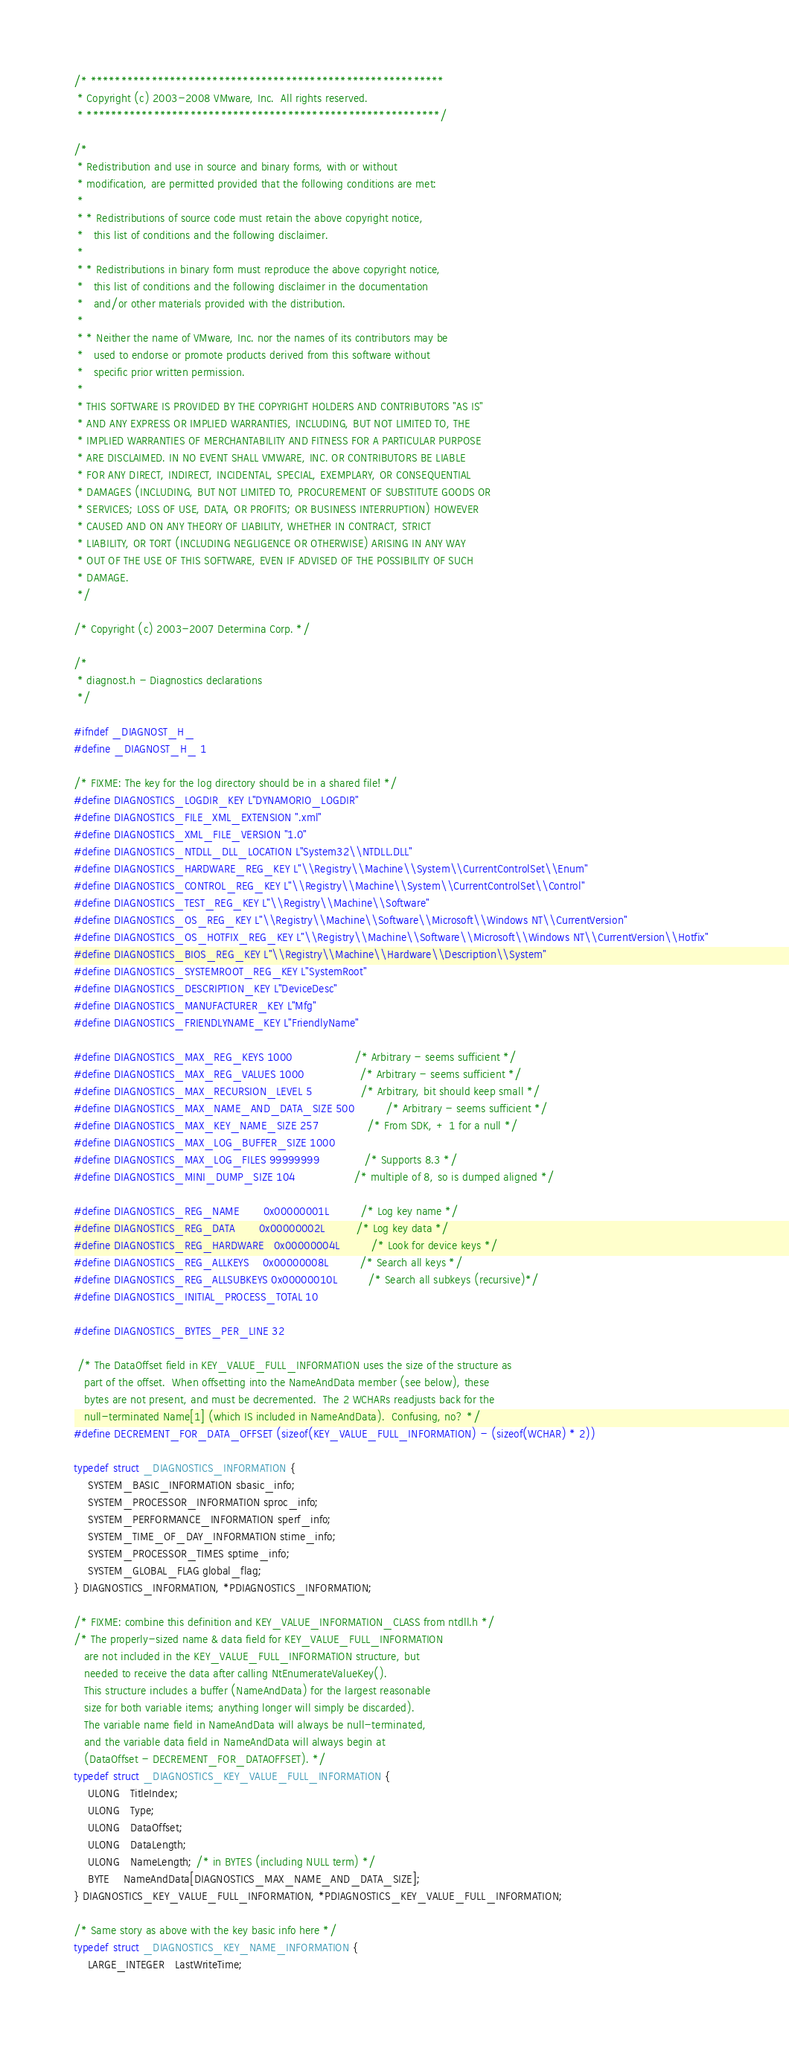Convert code to text. <code><loc_0><loc_0><loc_500><loc_500><_C_>/* **********************************************************
 * Copyright (c) 2003-2008 VMware, Inc.  All rights reserved.
 * **********************************************************/

/*
 * Redistribution and use in source and binary forms, with or without
 * modification, are permitted provided that the following conditions are met:
 * 
 * * Redistributions of source code must retain the above copyright notice,
 *   this list of conditions and the following disclaimer.
 * 
 * * Redistributions in binary form must reproduce the above copyright notice,
 *   this list of conditions and the following disclaimer in the documentation
 *   and/or other materials provided with the distribution.
 * 
 * * Neither the name of VMware, Inc. nor the names of its contributors may be
 *   used to endorse or promote products derived from this software without
 *   specific prior written permission.
 * 
 * THIS SOFTWARE IS PROVIDED BY THE COPYRIGHT HOLDERS AND CONTRIBUTORS "AS IS"
 * AND ANY EXPRESS OR IMPLIED WARRANTIES, INCLUDING, BUT NOT LIMITED TO, THE
 * IMPLIED WARRANTIES OF MERCHANTABILITY AND FITNESS FOR A PARTICULAR PURPOSE
 * ARE DISCLAIMED. IN NO EVENT SHALL VMWARE, INC. OR CONTRIBUTORS BE LIABLE
 * FOR ANY DIRECT, INDIRECT, INCIDENTAL, SPECIAL, EXEMPLARY, OR CONSEQUENTIAL
 * DAMAGES (INCLUDING, BUT NOT LIMITED TO, PROCUREMENT OF SUBSTITUTE GOODS OR
 * SERVICES; LOSS OF USE, DATA, OR PROFITS; OR BUSINESS INTERRUPTION) HOWEVER
 * CAUSED AND ON ANY THEORY OF LIABILITY, WHETHER IN CONTRACT, STRICT
 * LIABILITY, OR TORT (INCLUDING NEGLIGENCE OR OTHERWISE) ARISING IN ANY WAY
 * OUT OF THE USE OF THIS SOFTWARE, EVEN IF ADVISED OF THE POSSIBILITY OF SUCH
 * DAMAGE.
 */

/* Copyright (c) 2003-2007 Determina Corp. */

/*
 * diagnost.h - Diagnostics declarations
 */

#ifndef _DIAGNOST_H_
#define _DIAGNOST_H_ 1

/* FIXME: The key for the log directory should be in a shared file! */
#define DIAGNOSTICS_LOGDIR_KEY L"DYNAMORIO_LOGDIR"
#define DIAGNOSTICS_FILE_XML_EXTENSION ".xml"
#define DIAGNOSTICS_XML_FILE_VERSION "1.0"
#define DIAGNOSTICS_NTDLL_DLL_LOCATION L"System32\\NTDLL.DLL"
#define DIAGNOSTICS_HARDWARE_REG_KEY L"\\Registry\\Machine\\System\\CurrentControlSet\\Enum"
#define DIAGNOSTICS_CONTROL_REG_KEY L"\\Registry\\Machine\\System\\CurrentControlSet\\Control"
#define DIAGNOSTICS_TEST_REG_KEY L"\\Registry\\Machine\\Software"
#define DIAGNOSTICS_OS_REG_KEY L"\\Registry\\Machine\\Software\\Microsoft\\Windows NT\\CurrentVersion"
#define DIAGNOSTICS_OS_HOTFIX_REG_KEY L"\\Registry\\Machine\\Software\\Microsoft\\Windows NT\\CurrentVersion\\Hotfix"  
#define DIAGNOSTICS_BIOS_REG_KEY L"\\Registry\\Machine\\Hardware\\Description\\System"
#define DIAGNOSTICS_SYSTEMROOT_REG_KEY L"SystemRoot"
#define DIAGNOSTICS_DESCRIPTION_KEY L"DeviceDesc"
#define DIAGNOSTICS_MANUFACTURER_KEY L"Mfg"
#define DIAGNOSTICS_FRIENDLYNAME_KEY L"FriendlyName"

#define DIAGNOSTICS_MAX_REG_KEYS 1000                  /* Arbitrary - seems sufficient */
#define DIAGNOSTICS_MAX_REG_VALUES 1000                /* Arbitrary - seems sufficient */
#define DIAGNOSTICS_MAX_RECURSION_LEVEL 5              /* Arbitrary, bit should keep small */
#define DIAGNOSTICS_MAX_NAME_AND_DATA_SIZE 500         /* Arbitrary - seems sufficient */
#define DIAGNOSTICS_MAX_KEY_NAME_SIZE 257              /* From SDK, + 1 for a null */
#define DIAGNOSTICS_MAX_LOG_BUFFER_SIZE 1000
#define DIAGNOSTICS_MAX_LOG_FILES 99999999             /* Supports 8.3 */
#define DIAGNOSTICS_MINI_DUMP_SIZE 104                 /* multiple of 8, so is dumped aligned */

#define DIAGNOSTICS_REG_NAME       0x00000001L         /* Log key name */
#define DIAGNOSTICS_REG_DATA       0x00000002L         /* Log key data */
#define DIAGNOSTICS_REG_HARDWARE   0x00000004L         /* Look for device keys */
#define DIAGNOSTICS_REG_ALLKEYS    0x00000008L         /* Search all keys */
#define DIAGNOSTICS_REG_ALLSUBKEYS 0x00000010L         /* Search all subkeys (recursive)*/
#define DIAGNOSTICS_INITIAL_PROCESS_TOTAL 10

#define DIAGNOSTICS_BYTES_PER_LINE 32

 /* The DataOffset field in KEY_VALUE_FULL_INFORMATION uses the size of the structure as 
   part of the offset.  When offsetting into the NameAndData member (see below), these
   bytes are not present, and must be decremented.  The 2 WCHARs readjusts back for the 
   null-terminated Name[1] (which IS included in NameAndData).  Confusing, no? */
#define DECREMENT_FOR_DATA_OFFSET (sizeof(KEY_VALUE_FULL_INFORMATION) - (sizeof(WCHAR) * 2))

typedef struct _DIAGNOSTICS_INFORMATION {
    SYSTEM_BASIC_INFORMATION sbasic_info;
    SYSTEM_PROCESSOR_INFORMATION sproc_info;
    SYSTEM_PERFORMANCE_INFORMATION sperf_info;
    SYSTEM_TIME_OF_DAY_INFORMATION stime_info;
    SYSTEM_PROCESSOR_TIMES sptime_info;
    SYSTEM_GLOBAL_FLAG global_flag;
} DIAGNOSTICS_INFORMATION, *PDIAGNOSTICS_INFORMATION; 

/* FIXME: combine this definition and KEY_VALUE_INFORMATION_CLASS from ntdll.h */
/* The properly-sized name & data field for KEY_VALUE_FULL_INFORMATION 
   are not included in the KEY_VALUE_FULL_INFORMATION structure, but 
   needed to receive the data after calling NtEnumerateValueKey().  
   This structure includes a buffer (NameAndData) for the largest reasonable 
   size for both variable items; anything longer will simply be discarded).
   The variable name field in NameAndData will always be null-terminated,
   and the variable data field in NameAndData will always begin at 
   (DataOffset - DECREMENT_FOR_DATAOFFSET). */
typedef struct _DIAGNOSTICS_KEY_VALUE_FULL_INFORMATION {
    ULONG   TitleIndex;
    ULONG   Type;
    ULONG   DataOffset;
    ULONG   DataLength;
    ULONG   NameLength; /* in BYTES (including NULL term) */
    BYTE    NameAndData[DIAGNOSTICS_MAX_NAME_AND_DATA_SIZE];
} DIAGNOSTICS_KEY_VALUE_FULL_INFORMATION, *PDIAGNOSTICS_KEY_VALUE_FULL_INFORMATION;

/* Same story as above with the key basic info here */
typedef struct _DIAGNOSTICS_KEY_NAME_INFORMATION {
    LARGE_INTEGER   LastWriteTime;</code> 